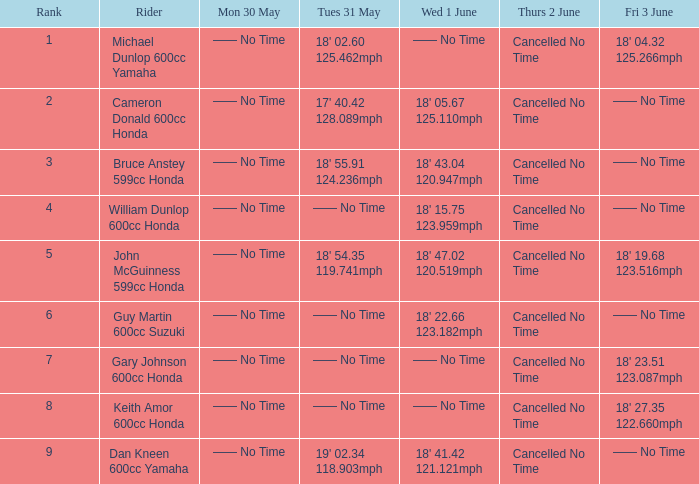What is the placement of the rider whose tues 31 may time was 19' 0 9.0. 